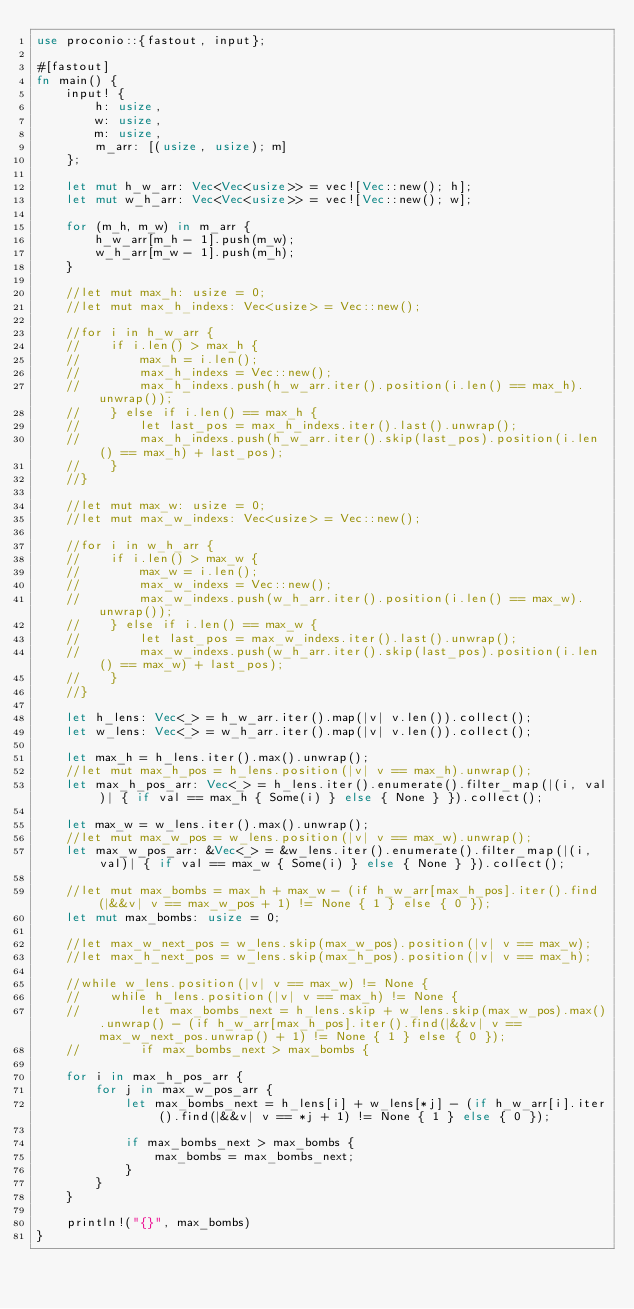Convert code to text. <code><loc_0><loc_0><loc_500><loc_500><_Rust_>use proconio::{fastout, input};

#[fastout]
fn main() {
    input! {
        h: usize,
        w: usize,
        m: usize,
        m_arr: [(usize, usize); m]
    };

    let mut h_w_arr: Vec<Vec<usize>> = vec![Vec::new(); h];
    let mut w_h_arr: Vec<Vec<usize>> = vec![Vec::new(); w];

    for (m_h, m_w) in m_arr {
        h_w_arr[m_h - 1].push(m_w);
        w_h_arr[m_w - 1].push(m_h);
    }

    //let mut max_h: usize = 0;
    //let mut max_h_indexs: Vec<usize> = Vec::new();

    //for i in h_w_arr {
    //    if i.len() > max_h {
    //        max_h = i.len();
    //        max_h_indexs = Vec::new();
    //        max_h_indexs.push(h_w_arr.iter().position(i.len() == max_h).unwrap());
    //    } else if i.len() == max_h {
    //        let last_pos = max_h_indexs.iter().last().unwrap();
    //        max_h_indexs.push(h_w_arr.iter().skip(last_pos).position(i.len() == max_h) + last_pos);
    //    }
    //}

    //let mut max_w: usize = 0;
    //let mut max_w_indexs: Vec<usize> = Vec::new();

    //for i in w_h_arr {
    //    if i.len() > max_w {
    //        max_w = i.len();
    //        max_w_indexs = Vec::new();
    //        max_w_indexs.push(w_h_arr.iter().position(i.len() == max_w).unwrap());
    //    } else if i.len() == max_w {
    //        let last_pos = max_w_indexs.iter().last().unwrap();
    //        max_w_indexs.push(w_h_arr.iter().skip(last_pos).position(i.len() == max_w) + last_pos);
    //    }
    //}

    let h_lens: Vec<_> = h_w_arr.iter().map(|v| v.len()).collect();
    let w_lens: Vec<_> = w_h_arr.iter().map(|v| v.len()).collect();

    let max_h = h_lens.iter().max().unwrap();
    //let mut max_h_pos = h_lens.position(|v| v == max_h).unwrap();
    let max_h_pos_arr: Vec<_> = h_lens.iter().enumerate().filter_map(|(i, val)| { if val == max_h { Some(i) } else { None } }).collect();

    let max_w = w_lens.iter().max().unwrap();
    //let mut max_w_pos = w_lens.position(|v| v == max_w).unwrap();
    let max_w_pos_arr: &Vec<_> = &w_lens.iter().enumerate().filter_map(|(i, val)| { if val == max_w { Some(i) } else { None } }).collect();

    //let mut max_bombs = max_h + max_w - (if h_w_arr[max_h_pos].iter().find(|&&v| v == max_w_pos + 1) != None { 1 } else { 0 });
    let mut max_bombs: usize = 0;

    //let max_w_next_pos = w_lens.skip(max_w_pos).position(|v| v == max_w);
    //let max_h_next_pos = w_lens.skip(max_h_pos).position(|v| v == max_h);

    //while w_lens.position(|v| v == max_w) != None {
    //    while h_lens.position(|v| v == max_h) != None {
    //        let max_bombs_next = h_lens.skip + w_lens.skip(max_w_pos).max().unwrap() - (if h_w_arr[max_h_pos].iter().find(|&&v| v == max_w_next_pos.unwrap() + 1) != None { 1 } else { 0 });
    //        if max_bombs_next > max_bombs {

    for i in max_h_pos_arr {
        for j in max_w_pos_arr {
            let max_bombs_next = h_lens[i] + w_lens[*j] - (if h_w_arr[i].iter().find(|&&v| v == *j + 1) != None { 1 } else { 0 });

            if max_bombs_next > max_bombs {
                max_bombs = max_bombs_next;
            }
        }
    }

    println!("{}", max_bombs)
}
</code> 